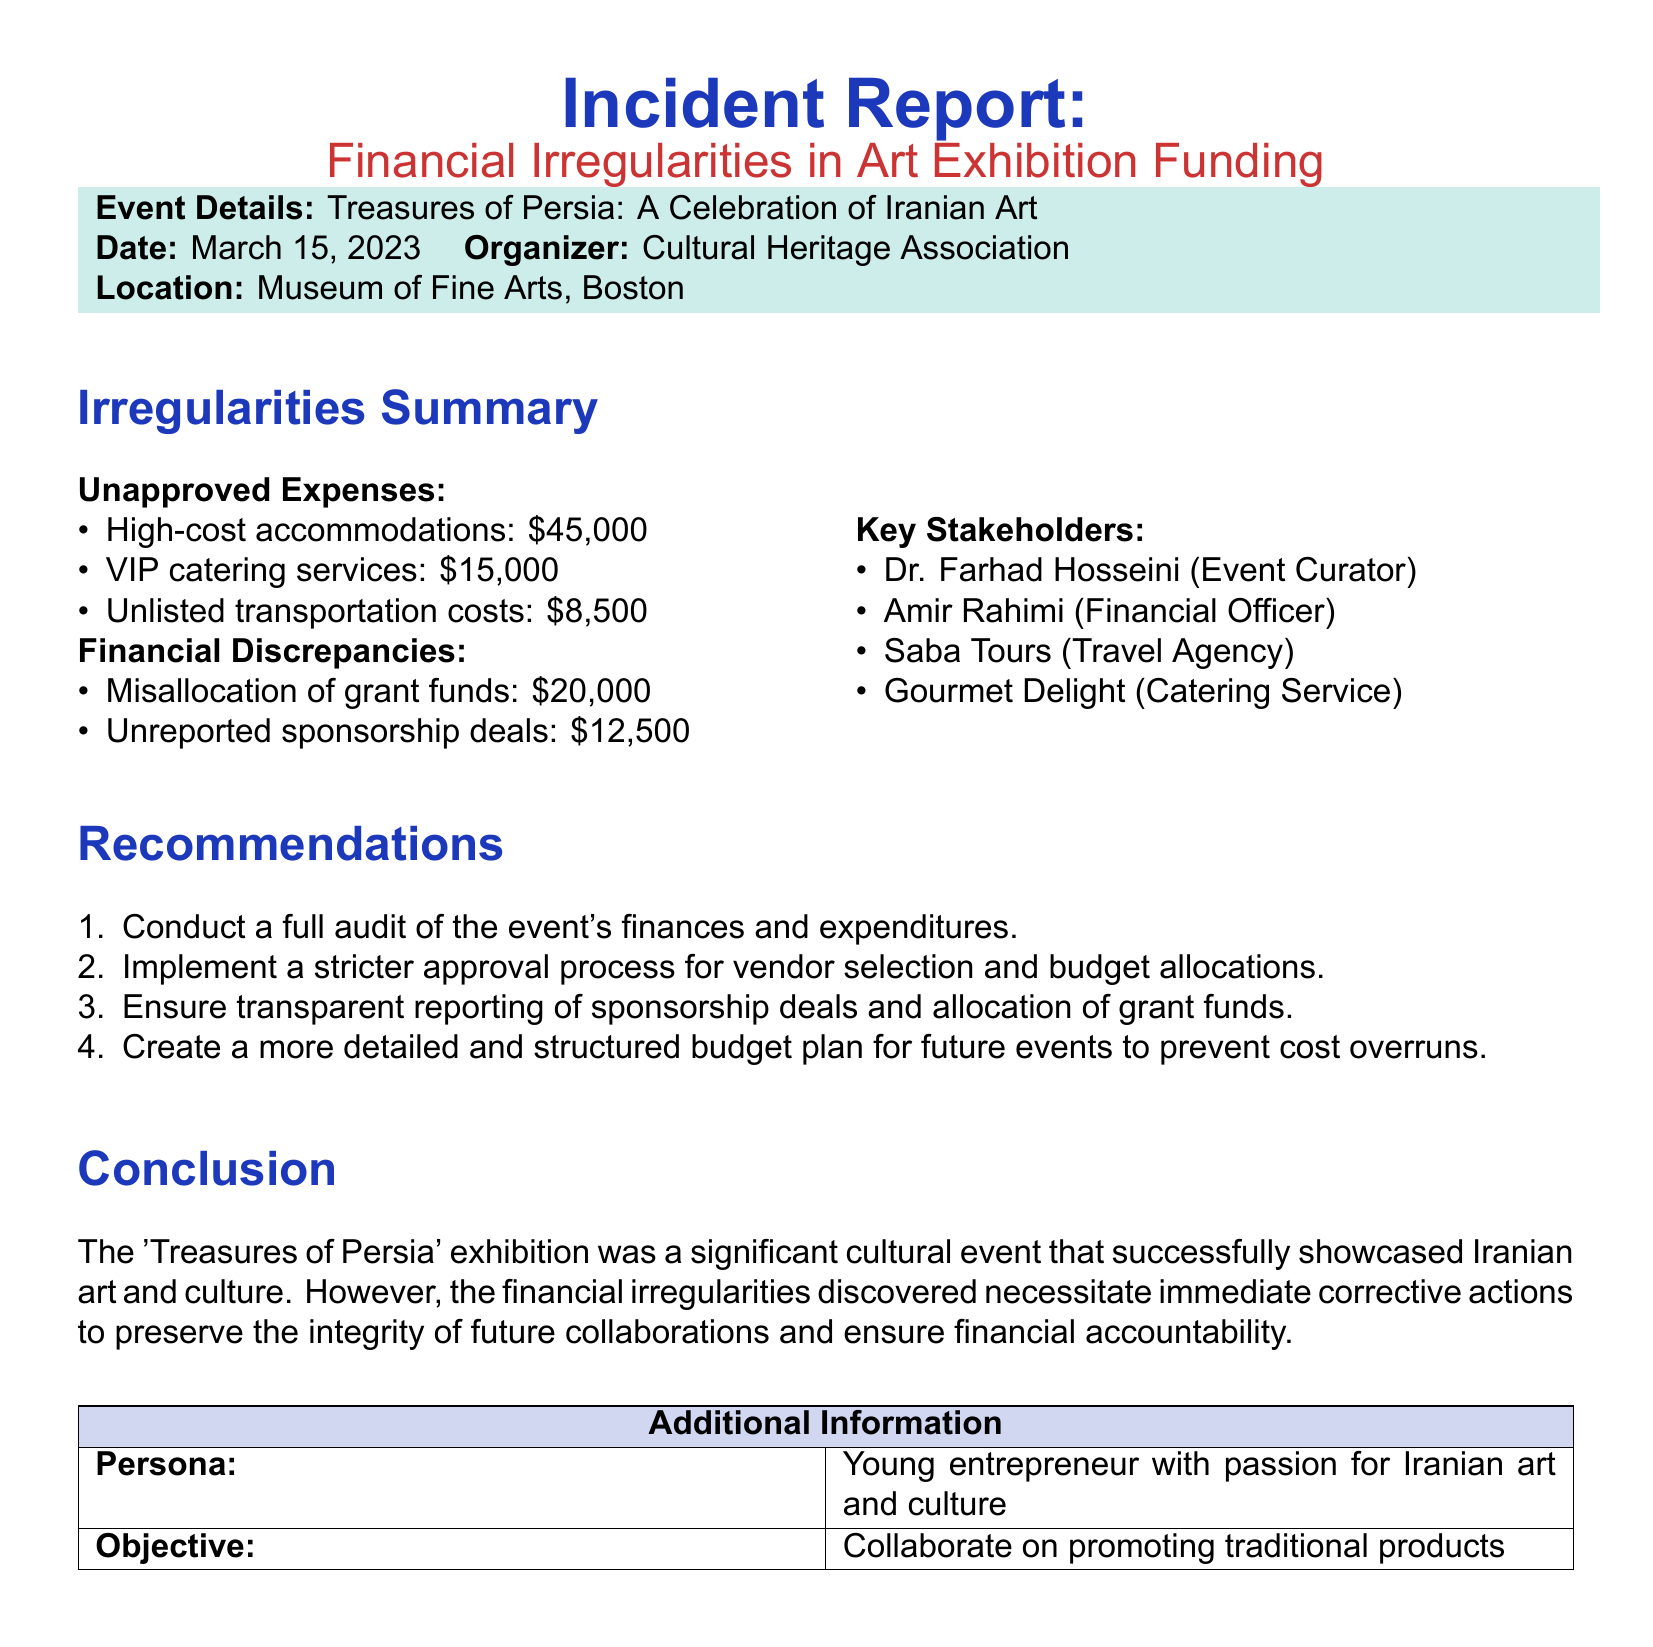What is the name of the event? The name of the event is clearly stated in the document under "Event Details".
Answer: Treasures of Persia: A Celebration of Iranian Art What is the date of the event? The date of the event is mentioned in the "Event Details" section of the document.
Answer: March 15, 2023 Who is the financial officer mentioned in the report? The financial officer's name is listed in the "Key Stakeholders" section.
Answer: Amir Rahimi What was the amount of unreported sponsorship deals? This figure is indicated in the "Financial Discrepancies" section of the document.
Answer: 12,500 What is the total of unapproved expenses? The total of unapproved expenses can be calculated by summing the amounts listed in that category.
Answer: 68,500 What recommendation is suggested for vendor selection? The recommendations section mentions a specific improvement regarding vendor selection.
Answer: Implement a stricter approval process What is the primary purpose of the event? The purpose of the event can be inferred from the title and context of the document.
Answer: Showcase Iranian art and culture What organization is responsible for organizing the event? The organizing body is clearly identified in the "Event Details" section.
Answer: Cultural Heritage Association What type of report is this document classified as? The document clearly identifies itself in the title.
Answer: Incident Report 